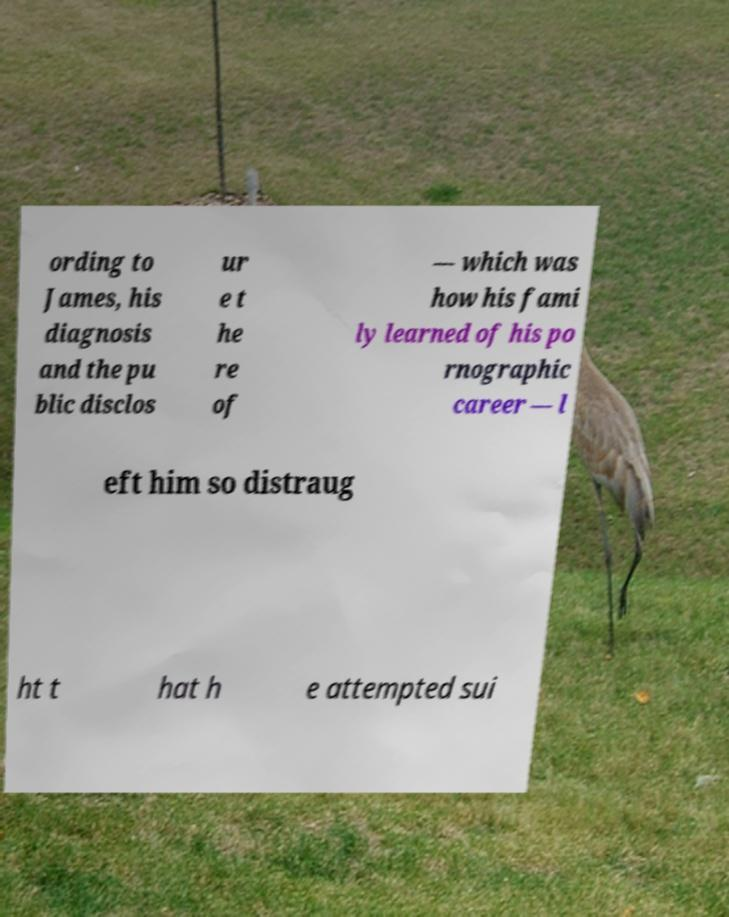Please identify and transcribe the text found in this image. ording to James, his diagnosis and the pu blic disclos ur e t he re of — which was how his fami ly learned of his po rnographic career — l eft him so distraug ht t hat h e attempted sui 